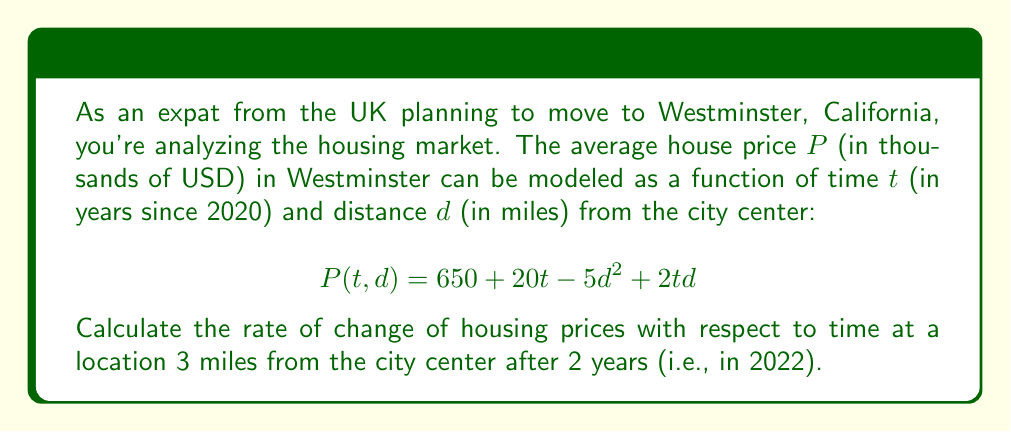Can you solve this math problem? To solve this problem, we need to use partial derivatives from multivariable calculus. We're interested in the rate of change with respect to time, so we'll use the partial derivative with respect to $t$.

Step 1: Calculate the partial derivative of $P$ with respect to $t$:
$$\frac{\partial P}{\partial t} = 20 + 2d$$

Step 2: We're asked about a location 3 miles from the city center, so substitute $d = 3$:
$$\frac{\partial P}{\partial t} = 20 + 2(3) = 20 + 6 = 26$$

Step 3: The question asks for the rate of change after 2 years, but note that the partial derivative we calculated is independent of $t$. This means the rate of change with respect to time is constant for any given distance from the city center.

Therefore, the rate of change of housing prices with respect to time, 3 miles from the city center, is 26 thousand USD per year.
Answer: $26$ thousand USD per year 